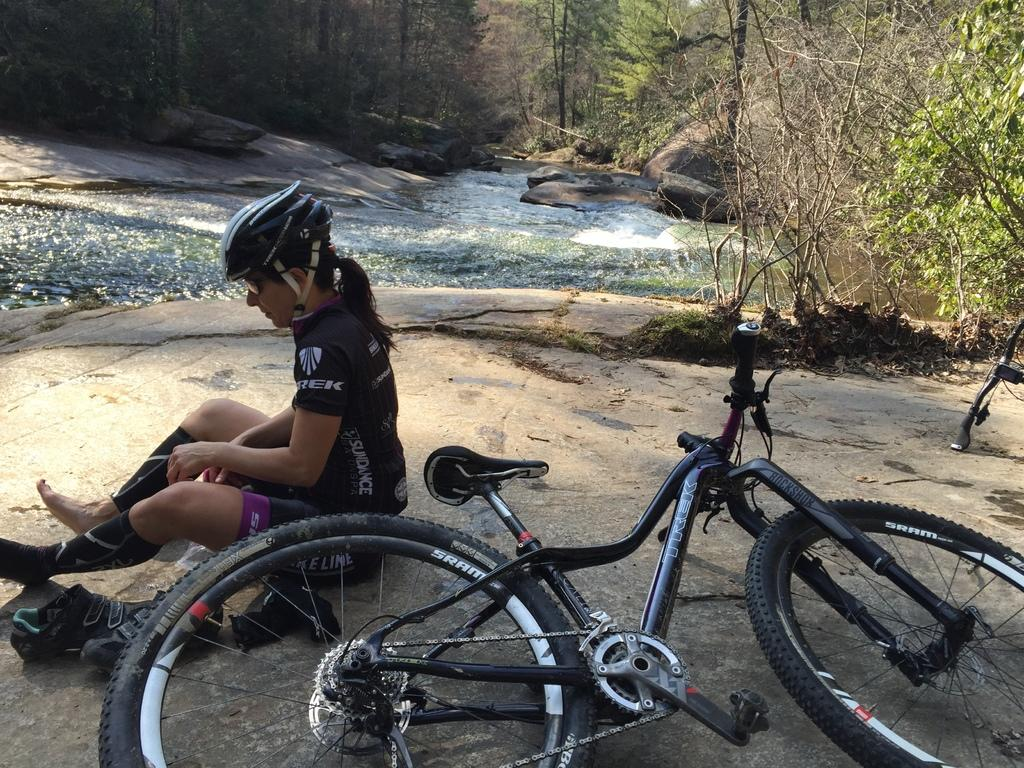What is the appearance of the woman in the image? There is a beautiful woman in the image. What is the woman doing in the image? The woman is sitting. What is the woman wearing in the image? The woman is wearing a black dress and a helmet. What object is associated with the woman in the image? There is a cycle in the image. What is the color of the cycle? The cycle is black in color. What natural element is present in the image? Water is flowing in the image. What type of vegetation can be seen in the image? There are trees in the image. How many shades of green can be seen on the woman's toes in the image? There is no mention of the woman's toes in the image, and therefore no shades of green can be observed. 